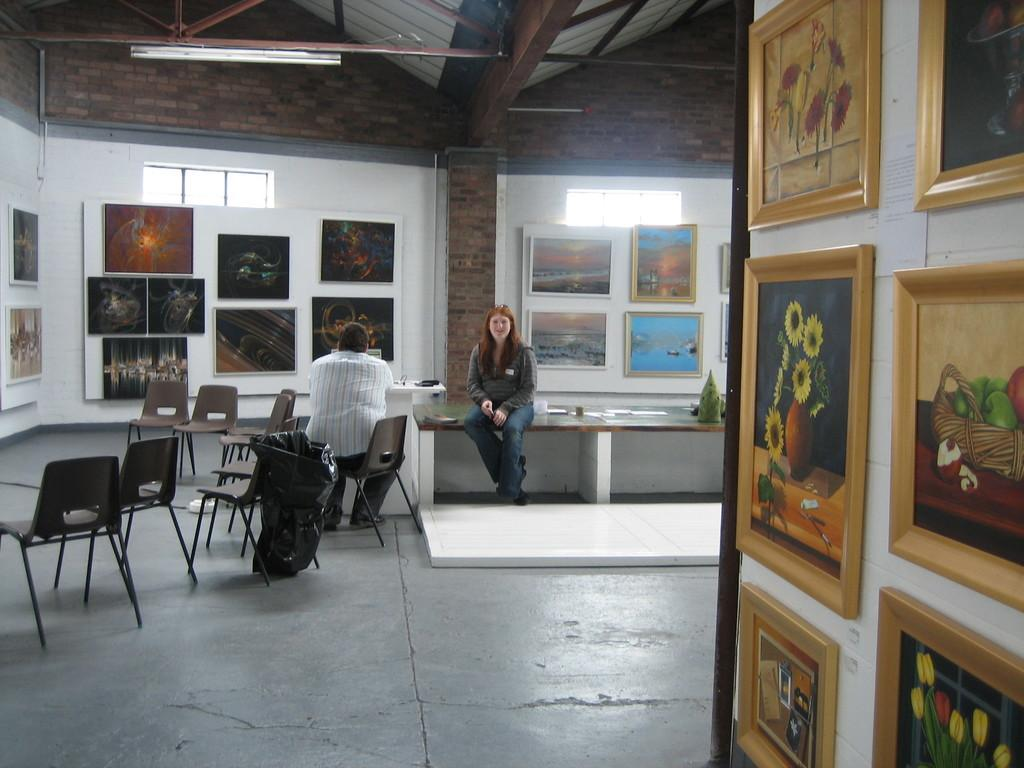What type of objects can be seen in the room in the image? There are many frames and chairs in the room. Can you describe the people in the image? There is a person and a woman in the image. How are the person and the woman positioned in the image? The person and the woman are sitting side by side. How does the crowd react to the bait in the image? There is no crowd or bait present in the image; it only features frames, chairs, a person, and a woman. 